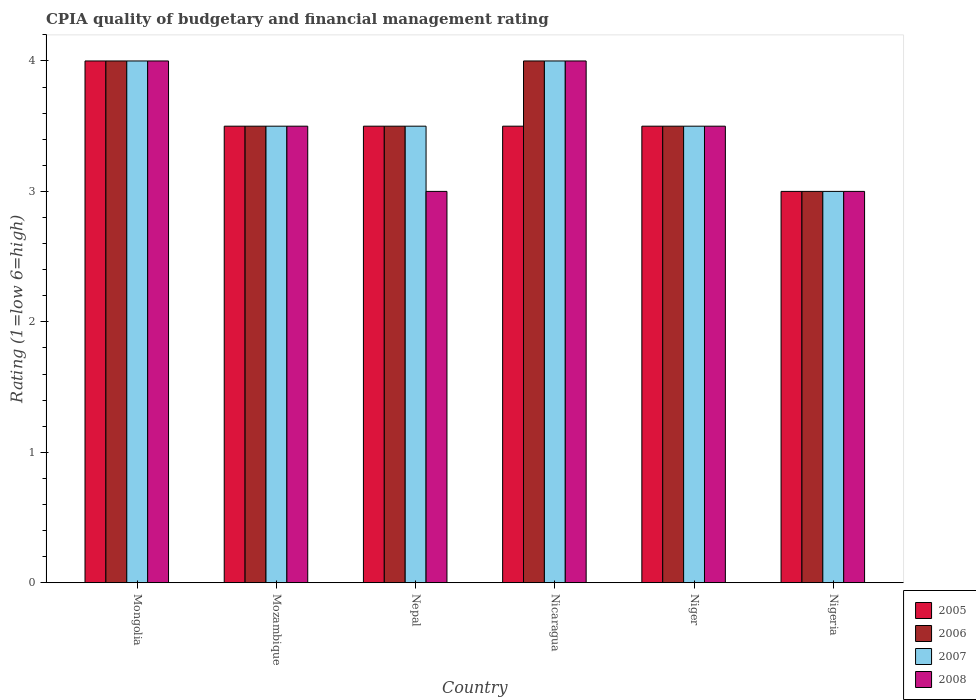How many different coloured bars are there?
Your answer should be compact. 4. Are the number of bars per tick equal to the number of legend labels?
Offer a very short reply. Yes. Are the number of bars on each tick of the X-axis equal?
Make the answer very short. Yes. How many bars are there on the 2nd tick from the left?
Your answer should be very brief. 4. How many bars are there on the 4th tick from the right?
Offer a terse response. 4. What is the label of the 4th group of bars from the left?
Provide a succinct answer. Nicaragua. What is the CPIA rating in 2007 in Niger?
Provide a short and direct response. 3.5. Across all countries, what is the maximum CPIA rating in 2006?
Ensure brevity in your answer.  4. In which country was the CPIA rating in 2006 maximum?
Ensure brevity in your answer.  Mongolia. In which country was the CPIA rating in 2005 minimum?
Your answer should be compact. Nigeria. What is the total CPIA rating in 2006 in the graph?
Your response must be concise. 21.5. What is the difference between the CPIA rating in 2008 in Mongolia and that in Nigeria?
Your answer should be compact. 1. What is the average CPIA rating in 2005 per country?
Ensure brevity in your answer.  3.5. In how many countries, is the CPIA rating in 2006 greater than 3.4?
Give a very brief answer. 5. Is the difference between the CPIA rating in 2007 in Mongolia and Nigeria greater than the difference between the CPIA rating in 2008 in Mongolia and Nigeria?
Your answer should be very brief. No. What is the difference between the highest and the second highest CPIA rating in 2006?
Offer a very short reply. -0.5. What is the difference between the highest and the lowest CPIA rating in 2005?
Keep it short and to the point. 1. Is it the case that in every country, the sum of the CPIA rating in 2008 and CPIA rating in 2005 is greater than the sum of CPIA rating in 2006 and CPIA rating in 2007?
Make the answer very short. No. What does the 4th bar from the left in Niger represents?
Ensure brevity in your answer.  2008. How many bars are there?
Provide a short and direct response. 24. What is the difference between two consecutive major ticks on the Y-axis?
Offer a terse response. 1. Are the values on the major ticks of Y-axis written in scientific E-notation?
Provide a succinct answer. No. Does the graph contain grids?
Offer a terse response. No. How many legend labels are there?
Provide a short and direct response. 4. What is the title of the graph?
Provide a short and direct response. CPIA quality of budgetary and financial management rating. What is the Rating (1=low 6=high) in 2005 in Mongolia?
Offer a terse response. 4. What is the Rating (1=low 6=high) in 2005 in Mozambique?
Give a very brief answer. 3.5. What is the Rating (1=low 6=high) in 2007 in Mozambique?
Give a very brief answer. 3.5. What is the Rating (1=low 6=high) in 2005 in Nepal?
Ensure brevity in your answer.  3.5. What is the Rating (1=low 6=high) of 2007 in Nepal?
Your answer should be compact. 3.5. What is the Rating (1=low 6=high) of 2008 in Nepal?
Your answer should be very brief. 3. What is the Rating (1=low 6=high) in 2007 in Nicaragua?
Your answer should be very brief. 4. What is the Rating (1=low 6=high) of 2005 in Nigeria?
Give a very brief answer. 3. What is the Rating (1=low 6=high) of 2006 in Nigeria?
Offer a terse response. 3. Across all countries, what is the maximum Rating (1=low 6=high) in 2008?
Provide a succinct answer. 4. Across all countries, what is the minimum Rating (1=low 6=high) of 2005?
Keep it short and to the point. 3. Across all countries, what is the minimum Rating (1=low 6=high) in 2006?
Make the answer very short. 3. Across all countries, what is the minimum Rating (1=low 6=high) of 2007?
Keep it short and to the point. 3. Across all countries, what is the minimum Rating (1=low 6=high) of 2008?
Offer a terse response. 3. What is the total Rating (1=low 6=high) in 2005 in the graph?
Provide a short and direct response. 21. What is the difference between the Rating (1=low 6=high) in 2006 in Mongolia and that in Mozambique?
Provide a short and direct response. 0.5. What is the difference between the Rating (1=low 6=high) of 2007 in Mongolia and that in Mozambique?
Make the answer very short. 0.5. What is the difference between the Rating (1=low 6=high) of 2008 in Mongolia and that in Mozambique?
Give a very brief answer. 0.5. What is the difference between the Rating (1=low 6=high) in 2006 in Mongolia and that in Nepal?
Offer a terse response. 0.5. What is the difference between the Rating (1=low 6=high) in 2005 in Mongolia and that in Nicaragua?
Provide a succinct answer. 0.5. What is the difference between the Rating (1=low 6=high) of 2007 in Mongolia and that in Nicaragua?
Offer a very short reply. 0. What is the difference between the Rating (1=low 6=high) of 2008 in Mongolia and that in Niger?
Offer a terse response. 0.5. What is the difference between the Rating (1=low 6=high) in 2005 in Mongolia and that in Nigeria?
Provide a short and direct response. 1. What is the difference between the Rating (1=low 6=high) of 2006 in Mongolia and that in Nigeria?
Your response must be concise. 1. What is the difference between the Rating (1=low 6=high) of 2008 in Mongolia and that in Nigeria?
Offer a very short reply. 1. What is the difference between the Rating (1=low 6=high) in 2008 in Mozambique and that in Nepal?
Make the answer very short. 0.5. What is the difference between the Rating (1=low 6=high) of 2005 in Mozambique and that in Nicaragua?
Offer a terse response. 0. What is the difference between the Rating (1=low 6=high) of 2007 in Mozambique and that in Nicaragua?
Make the answer very short. -0.5. What is the difference between the Rating (1=low 6=high) in 2005 in Mozambique and that in Niger?
Keep it short and to the point. 0. What is the difference between the Rating (1=low 6=high) of 2006 in Mozambique and that in Niger?
Your answer should be very brief. 0. What is the difference between the Rating (1=low 6=high) of 2008 in Mozambique and that in Niger?
Offer a very short reply. 0. What is the difference between the Rating (1=low 6=high) of 2005 in Mozambique and that in Nigeria?
Provide a short and direct response. 0.5. What is the difference between the Rating (1=low 6=high) of 2006 in Mozambique and that in Nigeria?
Your response must be concise. 0.5. What is the difference between the Rating (1=low 6=high) in 2007 in Mozambique and that in Nigeria?
Offer a very short reply. 0.5. What is the difference between the Rating (1=low 6=high) in 2008 in Mozambique and that in Nigeria?
Provide a short and direct response. 0.5. What is the difference between the Rating (1=low 6=high) of 2005 in Nepal and that in Nicaragua?
Keep it short and to the point. 0. What is the difference between the Rating (1=low 6=high) of 2006 in Nepal and that in Nicaragua?
Keep it short and to the point. -0.5. What is the difference between the Rating (1=low 6=high) in 2005 in Nepal and that in Niger?
Keep it short and to the point. 0. What is the difference between the Rating (1=low 6=high) of 2006 in Nepal and that in Niger?
Make the answer very short. 0. What is the difference between the Rating (1=low 6=high) of 2007 in Nepal and that in Niger?
Make the answer very short. 0. What is the difference between the Rating (1=low 6=high) in 2005 in Nepal and that in Nigeria?
Give a very brief answer. 0.5. What is the difference between the Rating (1=low 6=high) of 2006 in Nepal and that in Nigeria?
Provide a succinct answer. 0.5. What is the difference between the Rating (1=low 6=high) of 2005 in Nicaragua and that in Niger?
Keep it short and to the point. 0. What is the difference between the Rating (1=low 6=high) in 2007 in Nicaragua and that in Niger?
Offer a terse response. 0.5. What is the difference between the Rating (1=low 6=high) in 2006 in Nicaragua and that in Nigeria?
Your answer should be very brief. 1. What is the difference between the Rating (1=low 6=high) in 2008 in Nicaragua and that in Nigeria?
Give a very brief answer. 1. What is the difference between the Rating (1=low 6=high) of 2005 in Niger and that in Nigeria?
Your answer should be compact. 0.5. What is the difference between the Rating (1=low 6=high) in 2006 in Niger and that in Nigeria?
Give a very brief answer. 0.5. What is the difference between the Rating (1=low 6=high) in 2008 in Niger and that in Nigeria?
Offer a very short reply. 0.5. What is the difference between the Rating (1=low 6=high) of 2005 in Mongolia and the Rating (1=low 6=high) of 2006 in Mozambique?
Your response must be concise. 0.5. What is the difference between the Rating (1=low 6=high) in 2006 in Mongolia and the Rating (1=low 6=high) in 2008 in Mozambique?
Make the answer very short. 0.5. What is the difference between the Rating (1=low 6=high) of 2007 in Mongolia and the Rating (1=low 6=high) of 2008 in Mozambique?
Offer a very short reply. 0.5. What is the difference between the Rating (1=low 6=high) in 2005 in Mongolia and the Rating (1=low 6=high) in 2007 in Nepal?
Keep it short and to the point. 0.5. What is the difference between the Rating (1=low 6=high) of 2005 in Mongolia and the Rating (1=low 6=high) of 2007 in Nicaragua?
Give a very brief answer. 0. What is the difference between the Rating (1=low 6=high) in 2005 in Mongolia and the Rating (1=low 6=high) in 2008 in Nicaragua?
Give a very brief answer. 0. What is the difference between the Rating (1=low 6=high) in 2006 in Mongolia and the Rating (1=low 6=high) in 2008 in Nicaragua?
Provide a short and direct response. 0. What is the difference between the Rating (1=low 6=high) of 2007 in Mongolia and the Rating (1=low 6=high) of 2008 in Nicaragua?
Offer a very short reply. 0. What is the difference between the Rating (1=low 6=high) of 2005 in Mongolia and the Rating (1=low 6=high) of 2007 in Niger?
Your answer should be very brief. 0.5. What is the difference between the Rating (1=low 6=high) in 2006 in Mongolia and the Rating (1=low 6=high) in 2008 in Niger?
Provide a short and direct response. 0.5. What is the difference between the Rating (1=low 6=high) of 2007 in Mongolia and the Rating (1=low 6=high) of 2008 in Niger?
Your answer should be very brief. 0.5. What is the difference between the Rating (1=low 6=high) in 2005 in Mongolia and the Rating (1=low 6=high) in 2006 in Nigeria?
Your response must be concise. 1. What is the difference between the Rating (1=low 6=high) in 2005 in Mongolia and the Rating (1=low 6=high) in 2007 in Nigeria?
Your answer should be compact. 1. What is the difference between the Rating (1=low 6=high) of 2006 in Mongolia and the Rating (1=low 6=high) of 2008 in Nigeria?
Provide a succinct answer. 1. What is the difference between the Rating (1=low 6=high) in 2005 in Mozambique and the Rating (1=low 6=high) in 2006 in Nepal?
Provide a succinct answer. 0. What is the difference between the Rating (1=low 6=high) of 2005 in Mozambique and the Rating (1=low 6=high) of 2007 in Nicaragua?
Make the answer very short. -0.5. What is the difference between the Rating (1=low 6=high) in 2005 in Mozambique and the Rating (1=low 6=high) in 2008 in Nicaragua?
Your answer should be compact. -0.5. What is the difference between the Rating (1=low 6=high) of 2006 in Mozambique and the Rating (1=low 6=high) of 2007 in Nicaragua?
Give a very brief answer. -0.5. What is the difference between the Rating (1=low 6=high) of 2006 in Mozambique and the Rating (1=low 6=high) of 2008 in Nicaragua?
Your answer should be compact. -0.5. What is the difference between the Rating (1=low 6=high) of 2005 in Mozambique and the Rating (1=low 6=high) of 2006 in Niger?
Offer a very short reply. 0. What is the difference between the Rating (1=low 6=high) of 2005 in Mozambique and the Rating (1=low 6=high) of 2007 in Niger?
Give a very brief answer. 0. What is the difference between the Rating (1=low 6=high) in 2005 in Mozambique and the Rating (1=low 6=high) in 2007 in Nigeria?
Make the answer very short. 0.5. What is the difference between the Rating (1=low 6=high) of 2005 in Mozambique and the Rating (1=low 6=high) of 2008 in Nigeria?
Make the answer very short. 0.5. What is the difference between the Rating (1=low 6=high) in 2006 in Mozambique and the Rating (1=low 6=high) in 2007 in Nigeria?
Provide a succinct answer. 0.5. What is the difference between the Rating (1=low 6=high) of 2006 in Mozambique and the Rating (1=low 6=high) of 2008 in Nigeria?
Ensure brevity in your answer.  0.5. What is the difference between the Rating (1=low 6=high) of 2005 in Nepal and the Rating (1=low 6=high) of 2007 in Nicaragua?
Keep it short and to the point. -0.5. What is the difference between the Rating (1=low 6=high) in 2005 in Nepal and the Rating (1=low 6=high) in 2008 in Nicaragua?
Offer a terse response. -0.5. What is the difference between the Rating (1=low 6=high) of 2006 in Nepal and the Rating (1=low 6=high) of 2008 in Nicaragua?
Give a very brief answer. -0.5. What is the difference between the Rating (1=low 6=high) of 2007 in Nepal and the Rating (1=low 6=high) of 2008 in Nicaragua?
Provide a short and direct response. -0.5. What is the difference between the Rating (1=low 6=high) of 2005 in Nepal and the Rating (1=low 6=high) of 2006 in Niger?
Provide a short and direct response. 0. What is the difference between the Rating (1=low 6=high) in 2005 in Nepal and the Rating (1=low 6=high) in 2007 in Niger?
Your response must be concise. 0. What is the difference between the Rating (1=low 6=high) in 2006 in Nepal and the Rating (1=low 6=high) in 2008 in Niger?
Ensure brevity in your answer.  0. What is the difference between the Rating (1=low 6=high) of 2005 in Nicaragua and the Rating (1=low 6=high) of 2006 in Nigeria?
Provide a short and direct response. 0.5. What is the difference between the Rating (1=low 6=high) in 2005 in Nicaragua and the Rating (1=low 6=high) in 2007 in Nigeria?
Keep it short and to the point. 0.5. What is the difference between the Rating (1=low 6=high) of 2006 in Nicaragua and the Rating (1=low 6=high) of 2007 in Nigeria?
Make the answer very short. 1. What is the difference between the Rating (1=low 6=high) in 2005 in Niger and the Rating (1=low 6=high) in 2006 in Nigeria?
Offer a terse response. 0.5. What is the difference between the Rating (1=low 6=high) in 2006 in Niger and the Rating (1=low 6=high) in 2007 in Nigeria?
Make the answer very short. 0.5. What is the difference between the Rating (1=low 6=high) in 2007 in Niger and the Rating (1=low 6=high) in 2008 in Nigeria?
Your answer should be very brief. 0.5. What is the average Rating (1=low 6=high) of 2005 per country?
Offer a terse response. 3.5. What is the average Rating (1=low 6=high) in 2006 per country?
Provide a succinct answer. 3.58. What is the average Rating (1=low 6=high) of 2007 per country?
Make the answer very short. 3.58. What is the average Rating (1=low 6=high) of 2008 per country?
Provide a short and direct response. 3.5. What is the difference between the Rating (1=low 6=high) of 2005 and Rating (1=low 6=high) of 2008 in Mongolia?
Ensure brevity in your answer.  0. What is the difference between the Rating (1=low 6=high) of 2006 and Rating (1=low 6=high) of 2007 in Mongolia?
Your response must be concise. 0. What is the difference between the Rating (1=low 6=high) in 2006 and Rating (1=low 6=high) in 2008 in Mongolia?
Give a very brief answer. 0. What is the difference between the Rating (1=low 6=high) of 2005 and Rating (1=low 6=high) of 2007 in Mozambique?
Offer a very short reply. 0. What is the difference between the Rating (1=low 6=high) in 2005 and Rating (1=low 6=high) in 2008 in Mozambique?
Offer a very short reply. 0. What is the difference between the Rating (1=low 6=high) of 2007 and Rating (1=low 6=high) of 2008 in Mozambique?
Your answer should be compact. 0. What is the difference between the Rating (1=low 6=high) of 2005 and Rating (1=low 6=high) of 2007 in Nepal?
Provide a short and direct response. 0. What is the difference between the Rating (1=low 6=high) in 2005 and Rating (1=low 6=high) in 2008 in Nepal?
Your response must be concise. 0.5. What is the difference between the Rating (1=low 6=high) in 2006 and Rating (1=low 6=high) in 2007 in Nepal?
Make the answer very short. 0. What is the difference between the Rating (1=low 6=high) of 2006 and Rating (1=low 6=high) of 2008 in Nepal?
Offer a very short reply. 0.5. What is the difference between the Rating (1=low 6=high) of 2005 and Rating (1=low 6=high) of 2006 in Nicaragua?
Your answer should be very brief. -0.5. What is the difference between the Rating (1=low 6=high) in 2005 and Rating (1=low 6=high) in 2008 in Nicaragua?
Offer a terse response. -0.5. What is the difference between the Rating (1=low 6=high) of 2006 and Rating (1=low 6=high) of 2007 in Nicaragua?
Offer a very short reply. 0. What is the difference between the Rating (1=low 6=high) in 2006 and Rating (1=low 6=high) in 2008 in Nicaragua?
Your answer should be very brief. 0. What is the difference between the Rating (1=low 6=high) in 2007 and Rating (1=low 6=high) in 2008 in Nicaragua?
Offer a terse response. 0. What is the difference between the Rating (1=low 6=high) of 2006 and Rating (1=low 6=high) of 2008 in Niger?
Keep it short and to the point. 0. What is the difference between the Rating (1=low 6=high) in 2005 and Rating (1=low 6=high) in 2006 in Nigeria?
Provide a short and direct response. 0. What is the difference between the Rating (1=low 6=high) in 2005 and Rating (1=low 6=high) in 2007 in Nigeria?
Provide a short and direct response. 0. What is the difference between the Rating (1=low 6=high) of 2005 and Rating (1=low 6=high) of 2008 in Nigeria?
Give a very brief answer. 0. What is the ratio of the Rating (1=low 6=high) of 2007 in Mongolia to that in Mozambique?
Keep it short and to the point. 1.14. What is the ratio of the Rating (1=low 6=high) in 2006 in Mongolia to that in Nicaragua?
Keep it short and to the point. 1. What is the ratio of the Rating (1=low 6=high) of 2007 in Mongolia to that in Nicaragua?
Your answer should be compact. 1. What is the ratio of the Rating (1=low 6=high) of 2006 in Mongolia to that in Niger?
Give a very brief answer. 1.14. What is the ratio of the Rating (1=low 6=high) in 2007 in Mongolia to that in Niger?
Your answer should be very brief. 1.14. What is the ratio of the Rating (1=low 6=high) of 2005 in Mongolia to that in Nigeria?
Provide a succinct answer. 1.33. What is the ratio of the Rating (1=low 6=high) in 2006 in Mongolia to that in Nigeria?
Offer a terse response. 1.33. What is the ratio of the Rating (1=low 6=high) of 2007 in Mongolia to that in Nigeria?
Ensure brevity in your answer.  1.33. What is the ratio of the Rating (1=low 6=high) of 2008 in Mongolia to that in Nigeria?
Offer a terse response. 1.33. What is the ratio of the Rating (1=low 6=high) in 2005 in Mozambique to that in Nepal?
Provide a succinct answer. 1. What is the ratio of the Rating (1=low 6=high) of 2007 in Mozambique to that in Nepal?
Offer a very short reply. 1. What is the ratio of the Rating (1=low 6=high) of 2007 in Mozambique to that in Nicaragua?
Provide a succinct answer. 0.88. What is the ratio of the Rating (1=low 6=high) of 2005 in Mozambique to that in Niger?
Keep it short and to the point. 1. What is the ratio of the Rating (1=low 6=high) of 2006 in Mozambique to that in Niger?
Provide a short and direct response. 1. What is the ratio of the Rating (1=low 6=high) in 2006 in Mozambique to that in Nigeria?
Your answer should be very brief. 1.17. What is the ratio of the Rating (1=low 6=high) of 2007 in Mozambique to that in Nigeria?
Provide a succinct answer. 1.17. What is the ratio of the Rating (1=low 6=high) of 2008 in Mozambique to that in Nigeria?
Your answer should be compact. 1.17. What is the ratio of the Rating (1=low 6=high) of 2005 in Nepal to that in Nicaragua?
Provide a short and direct response. 1. What is the ratio of the Rating (1=low 6=high) of 2006 in Nepal to that in Nicaragua?
Make the answer very short. 0.88. What is the ratio of the Rating (1=low 6=high) in 2008 in Nepal to that in Nicaragua?
Your response must be concise. 0.75. What is the ratio of the Rating (1=low 6=high) in 2005 in Nepal to that in Niger?
Your answer should be very brief. 1. What is the ratio of the Rating (1=low 6=high) in 2006 in Nepal to that in Niger?
Your answer should be very brief. 1. What is the ratio of the Rating (1=low 6=high) of 2006 in Nepal to that in Nigeria?
Offer a terse response. 1.17. What is the ratio of the Rating (1=low 6=high) in 2008 in Nepal to that in Nigeria?
Ensure brevity in your answer.  1. What is the ratio of the Rating (1=low 6=high) in 2005 in Nicaragua to that in Niger?
Make the answer very short. 1. What is the ratio of the Rating (1=low 6=high) of 2006 in Nicaragua to that in Niger?
Your response must be concise. 1.14. What is the ratio of the Rating (1=low 6=high) of 2007 in Nicaragua to that in Niger?
Offer a very short reply. 1.14. What is the ratio of the Rating (1=low 6=high) in 2006 in Nicaragua to that in Nigeria?
Your answer should be compact. 1.33. What is the ratio of the Rating (1=low 6=high) of 2007 in Nicaragua to that in Nigeria?
Make the answer very short. 1.33. What is the ratio of the Rating (1=low 6=high) of 2006 in Niger to that in Nigeria?
Provide a short and direct response. 1.17. What is the difference between the highest and the second highest Rating (1=low 6=high) in 2007?
Provide a short and direct response. 0. What is the difference between the highest and the second highest Rating (1=low 6=high) in 2008?
Your response must be concise. 0. What is the difference between the highest and the lowest Rating (1=low 6=high) of 2006?
Keep it short and to the point. 1. What is the difference between the highest and the lowest Rating (1=low 6=high) in 2007?
Provide a short and direct response. 1. 